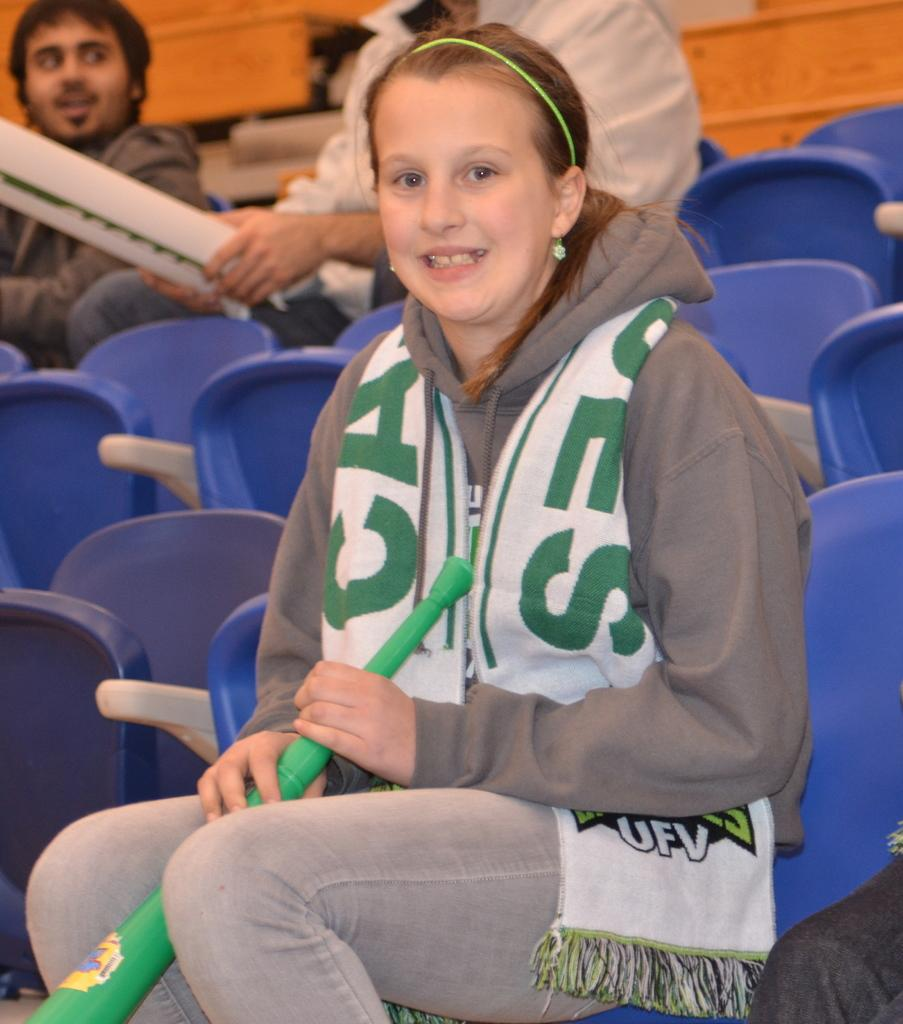<image>
Provide a brief description of the given image. A young girl holds a green horn and is wearing a scarf branded with UFV on it. 